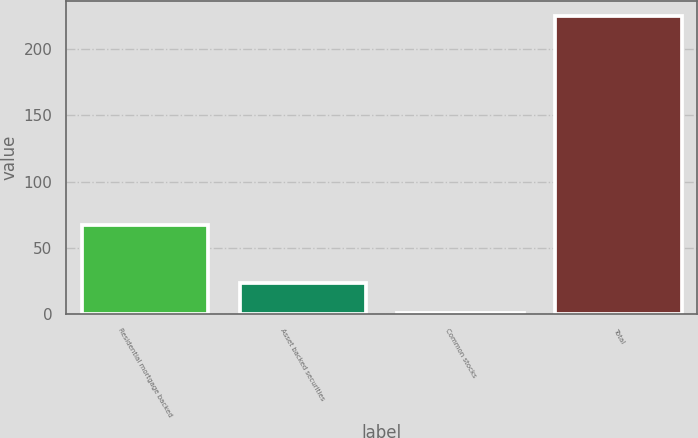Convert chart. <chart><loc_0><loc_0><loc_500><loc_500><bar_chart><fcel>Residential mortgage backed<fcel>Asset backed securities<fcel>Common stocks<fcel>Total<nl><fcel>67<fcel>23.4<fcel>1<fcel>225<nl></chart> 